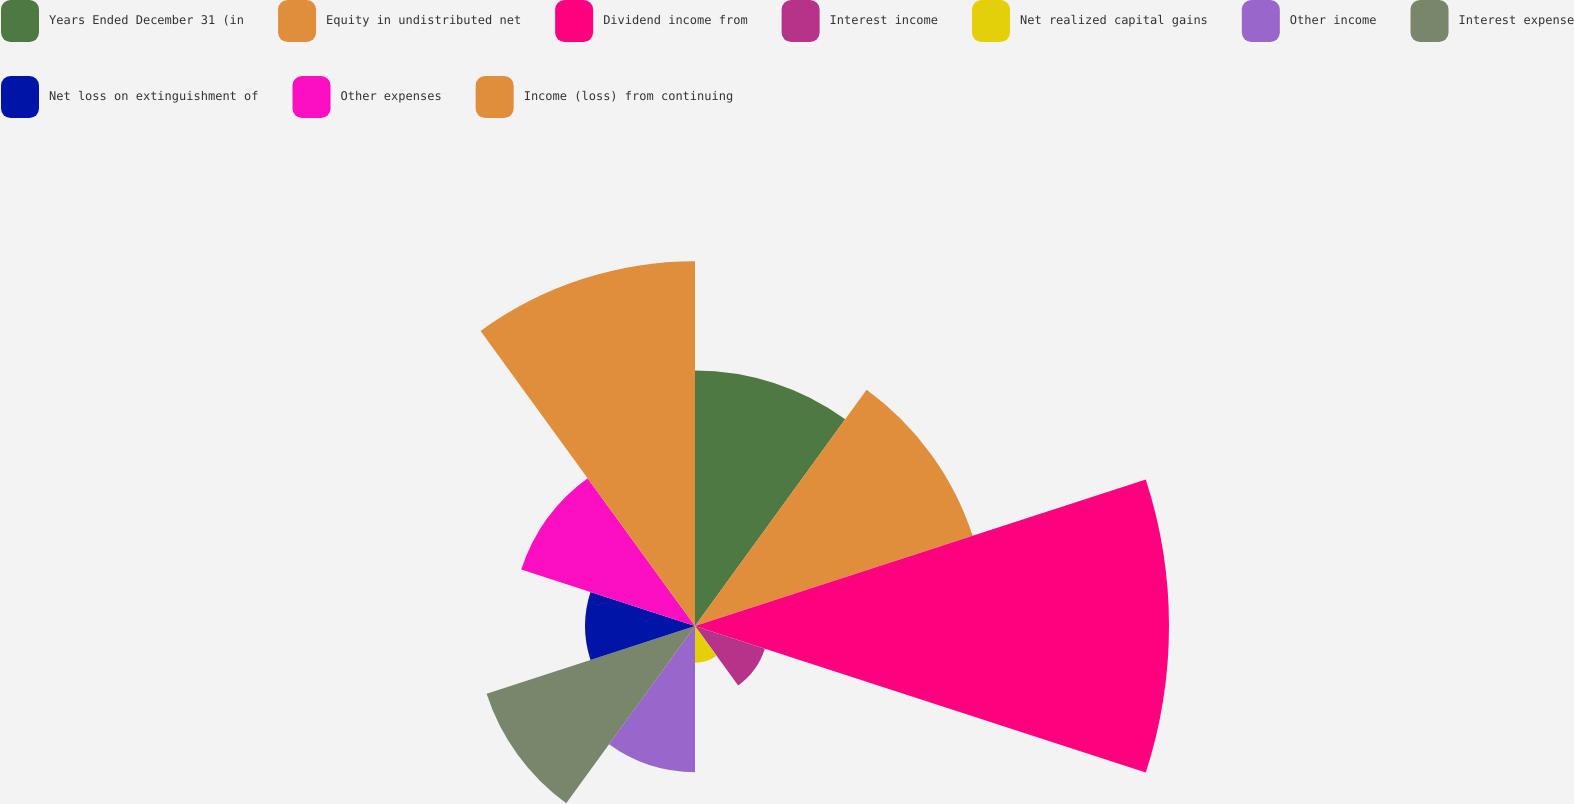<chart> <loc_0><loc_0><loc_500><loc_500><pie_chart><fcel>Years Ended December 31 (in<fcel>Equity in undistributed net<fcel>Dividend income from<fcel>Interest income<fcel>Net realized capital gains<fcel>Other income<fcel>Interest expense<fcel>Net loss on extinguishment of<fcel>Other expenses<fcel>Income (loss) from continuing<nl><fcel>11.86%<fcel>13.55%<fcel>22.0%<fcel>3.41%<fcel>1.71%<fcel>6.79%<fcel>10.17%<fcel>5.1%<fcel>8.48%<fcel>16.93%<nl></chart> 